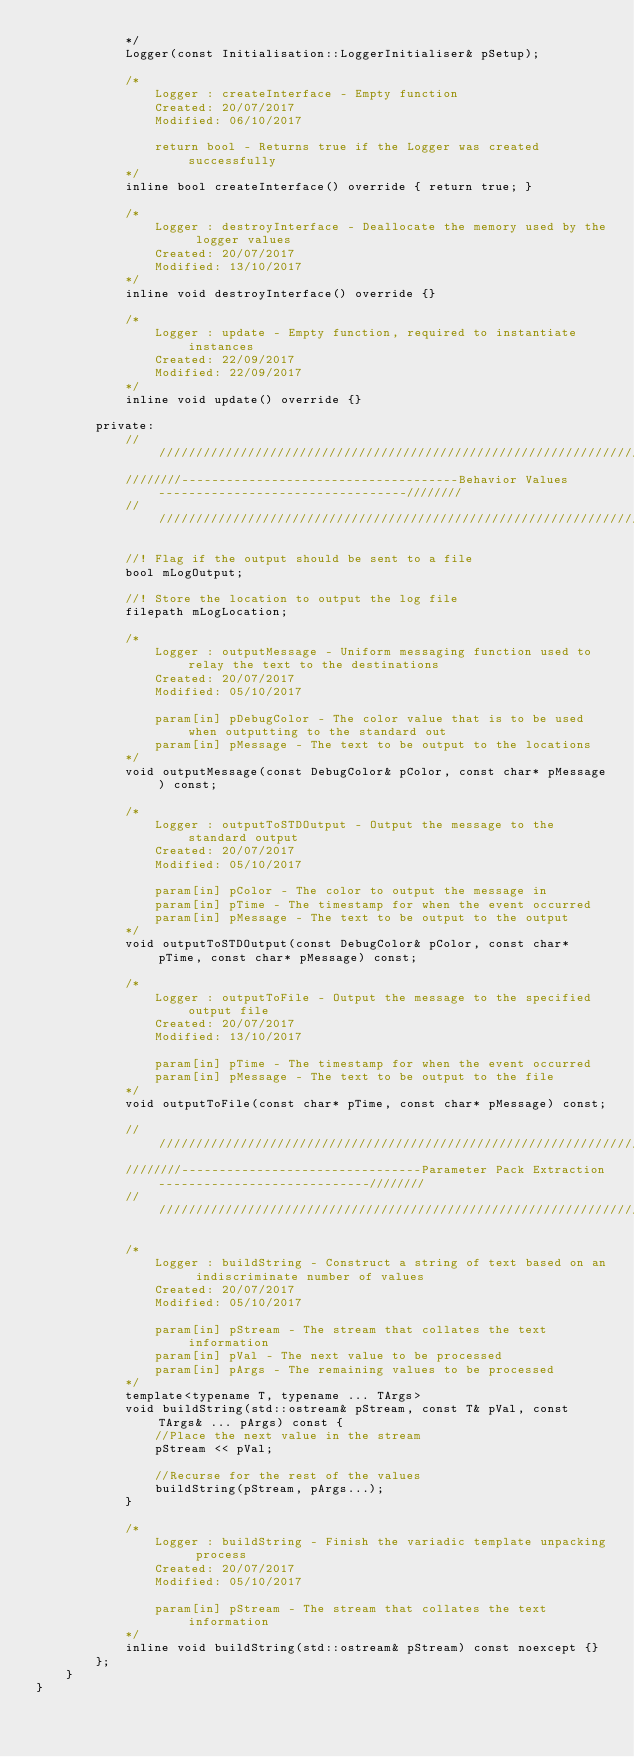Convert code to text. <code><loc_0><loc_0><loc_500><loc_500><_C++_>			*/
			Logger(const Initialisation::LoggerInitialiser& pSetup);

			/*
				Logger : createInterface - Empty function
				Created: 20/07/2017
				Modified: 06/10/2017

				return bool - Returns true if the Logger was created successfully
			*/
			inline bool createInterface() override { return true; }

			/*
				Logger : destroyInterface - Deallocate the memory used by the logger values
				Created: 20/07/2017
				Modified: 13/10/2017
			*/
			inline void destroyInterface() override {}

			/*
				Logger : update - Empty function, required to instantiate instances
				Created: 22/09/2017
				Modified: 22/09/2017
			*/
			inline void update() override {}

		private:
			/////////////////////////////////////////////////////////////////////////////////////////////////////
			////////-------------------------------------Behavior Values---------------------------------////////
			/////////////////////////////////////////////////////////////////////////////////////////////////////
			
			//! Flag if the output should be sent to a file
			bool mLogOutput;

			//! Store the location to output the log file
			filepath mLogLocation;
			
			/*
				Logger : outputMessage - Uniform messaging function used to relay the text to the destinations
				Created: 20/07/2017
				Modified: 05/10/2017

				param[in] pDebugColor - The color value that is to be used when outputting to the standard out
				param[in] pMessage - The text to be output to the locations
			*/
			void outputMessage(const DebugColor& pColor, const char* pMessage) const;

			/*
				Logger : outputToSTDOutput - Output the message to the standard output
				Created: 20/07/2017
				Modified: 05/10/2017

				param[in] pColor - The color to output the message in
				param[in] pTime - The timestamp for when the event occurred
				param[in] pMessage - The text to be output to the output
			*/
			void outputToSTDOutput(const DebugColor& pColor, const char* pTime, const char* pMessage) const;

			/*
				Logger : outputToFile - Output the message to the specified output file
				Created: 20/07/2017
				Modified: 13/10/2017

				param[in] pTime - The timestamp for when the event occurred
				param[in] pMessage - The text to be output to the file
			*/
			void outputToFile(const char* pTime, const char* pMessage) const;

			/////////////////////////////////////////////////////////////////////////////////////////////////////
			////////--------------------------------Parameter Pack Extraction----------------------------////////
			/////////////////////////////////////////////////////////////////////////////////////////////////////

			/*
				Logger : buildString - Construct a string of text based on an indiscriminate number of values
				Created: 20/07/2017
				Modified: 05/10/2017

				param[in] pStream - The stream that collates the text information
				param[in] pVal - The next value to be processed
				param[in] pArgs - The remaining values to be processed
			*/
			template<typename T, typename ... TArgs>
			void buildString(std::ostream& pStream, const T& pVal, const TArgs& ... pArgs) const {
				//Place the next value in the stream
				pStream << pVal;

				//Recurse for the rest of the values
				buildString(pStream, pArgs...);
			}

			/*
				Logger : buildString - Finish the variadic template unpacking process
				Created: 20/07/2017
				Modified: 05/10/2017

				param[in] pStream - The stream that collates the text information
			*/
			inline void buildString(std::ostream& pStream) const noexcept {}
		};
	}
}</code> 